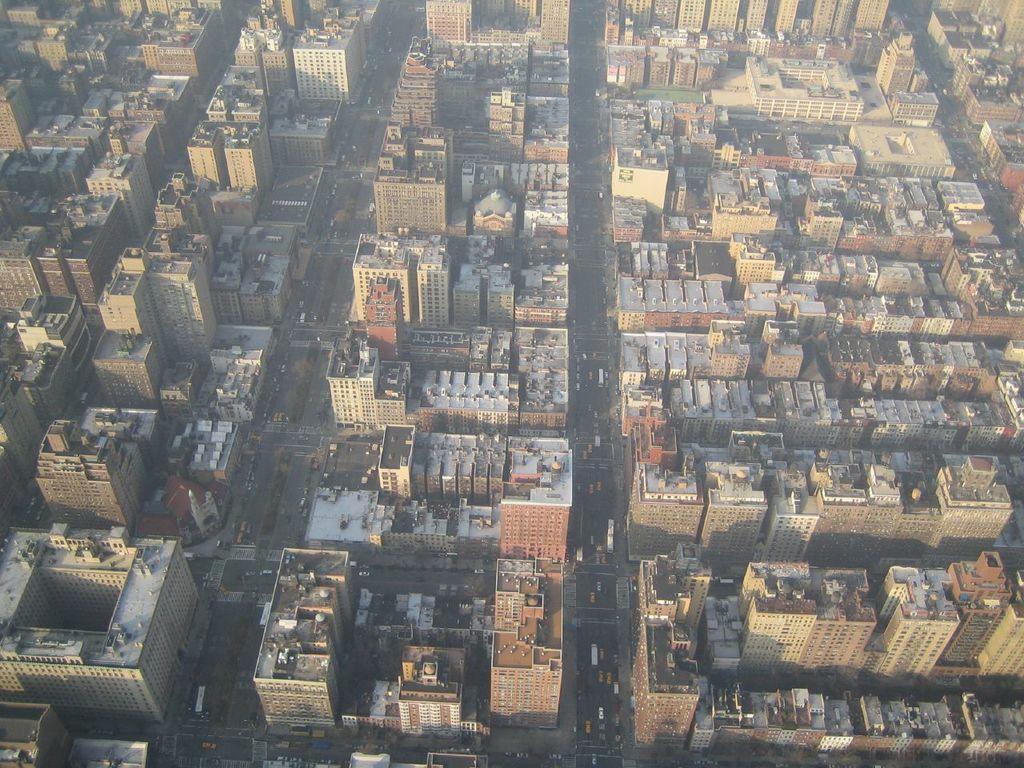In one or two sentences, can you explain what this image depicts? In this image we can see the complete view of the city where we can see tall buildings, roads and vehicles. 